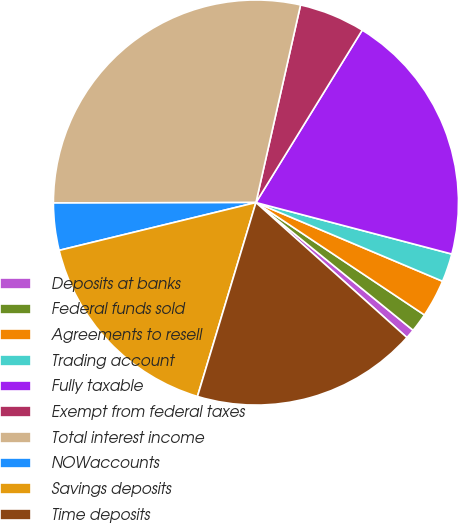Convert chart to OTSL. <chart><loc_0><loc_0><loc_500><loc_500><pie_chart><fcel>Deposits at banks<fcel>Federal funds sold<fcel>Agreements to resell<fcel>Trading account<fcel>Fully taxable<fcel>Exempt from federal taxes<fcel>Total interest income<fcel>NOWaccounts<fcel>Savings deposits<fcel>Time deposits<nl><fcel>0.75%<fcel>1.5%<fcel>3.01%<fcel>2.26%<fcel>20.3%<fcel>5.26%<fcel>28.57%<fcel>3.76%<fcel>16.54%<fcel>18.05%<nl></chart> 